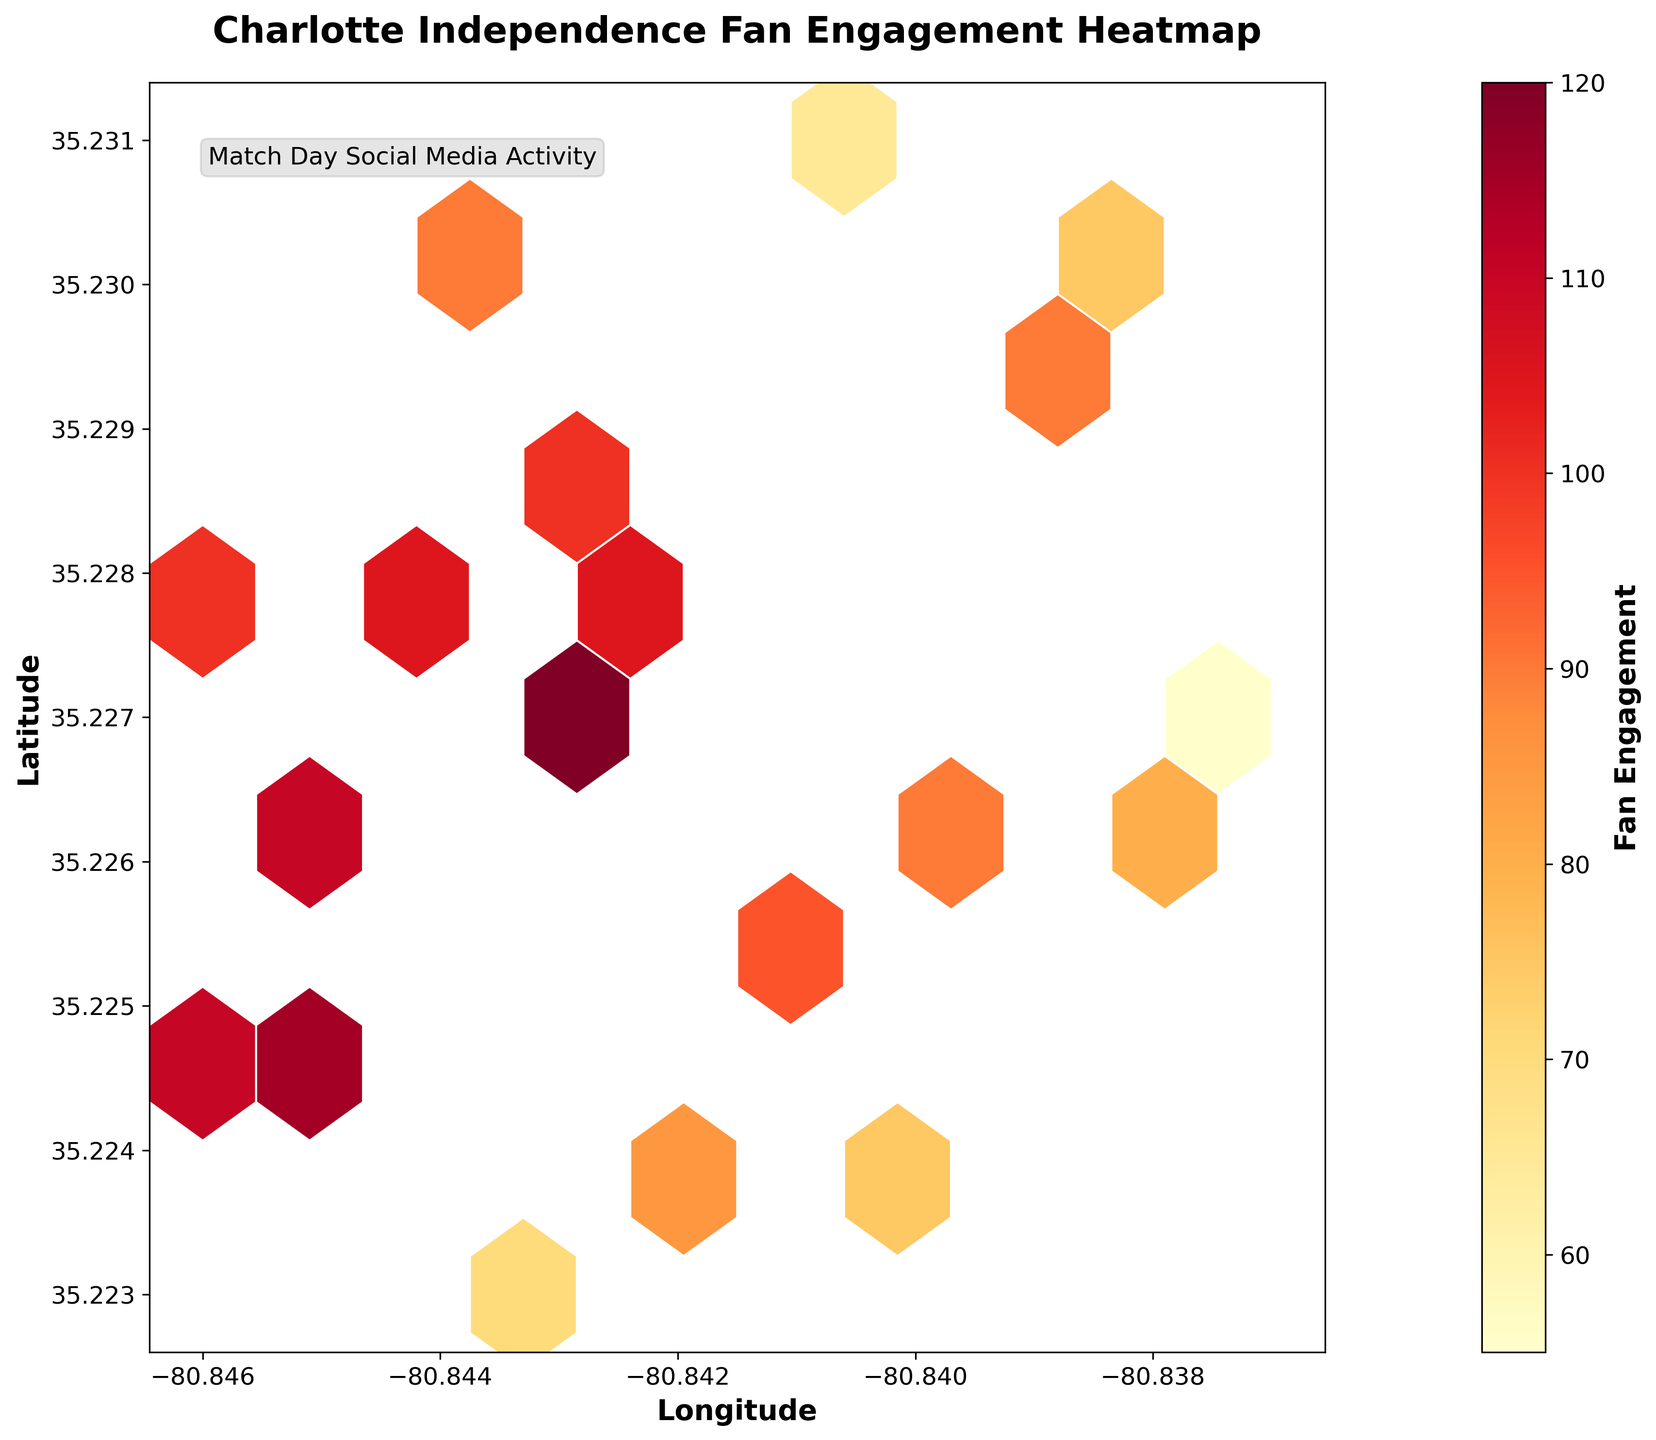What is the title of the plot? The title is located at the top center of the plot, prominently displayed in bold font. It reads "Charlotte Independence Fan Engagement Heatmap."
Answer: Charlotte Independence Fan Engagement Heatmap What do the colors in the hexbin cells represent? The colors represent different levels of fan engagement on match days, where the color scale ranges from yellow to red, with red indicating higher engagement.
Answer: Fan engagement levels Which axis displays latitude? The y-axis on the left side of the plot is labeled "Latitude," indicating it displays the latitude values.
Answer: Y-axis What is the range of engagement values as indicated by the colorbar? The colorbar on the right side of the plot shows the range of engagement values. By examining it, it spans from 55 to 120.
Answer: 55 to 120 What is the engagement level at the location with latitude 35.227 and longitude -80.843? By looking at the hexagonal bins near the specified coordinates and matching the color to the colorbar, we can approximate the engagement level. This location shows a high level of engagement.
Answer: Around 120 Which area, latitude 35.227 with longitude -80.843 or latitude 35.223 with longitude -80.843, has higher fan engagement? By comparing the color intensities at these coordinates, latitude 35.227 with longitude -80.843 shows a deeper color indicating higher engagement compared to latitude 35.223 with longitude -80.843.
Answer: 35.227, -80.843 What is the estimated fan engagement at latitude 35.226 and longitude -80.845? Observing the hexbin color near these coordinates and cross-referencing with the colorbar, the engagement is found to be approximately 110.
Answer: Around 110 What general trend can be noticed about fan engagement levels and their geographical distribution? By observing the plot, one can notice that fan engagement levels vary significantly, with some clusters showing high engagement (darker colors) and others lower engagement (lighter colors).
Answer: Highly variable What can be inferred about the engagement level at the coordinates (-80.841, 35.231)? Analyzing the hexbin color at these coordinates, we see a lighter color which corresponds to a lower engagement level on the color scale.
Answer: Around 65 